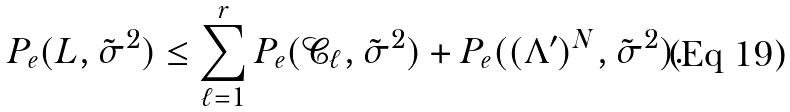<formula> <loc_0><loc_0><loc_500><loc_500>P _ { e } ( L , \tilde { \sigma } ^ { 2 } ) \leq \sum _ { \ell = 1 } ^ { r } { P _ { e } ( \mathcal { C } _ { \ell } , \tilde { \sigma } ^ { 2 } ) } + P _ { e } ( ( \Lambda ^ { \prime } ) ^ { N } , \tilde { \sigma } ^ { 2 } ) .</formula> 